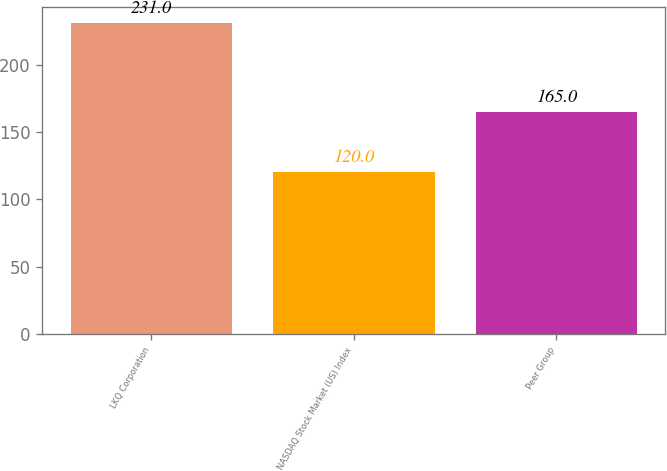Convert chart to OTSL. <chart><loc_0><loc_0><loc_500><loc_500><bar_chart><fcel>LKQ Corporation<fcel>NASDAQ Stock Market (US) Index<fcel>Peer Group<nl><fcel>231<fcel>120<fcel>165<nl></chart> 